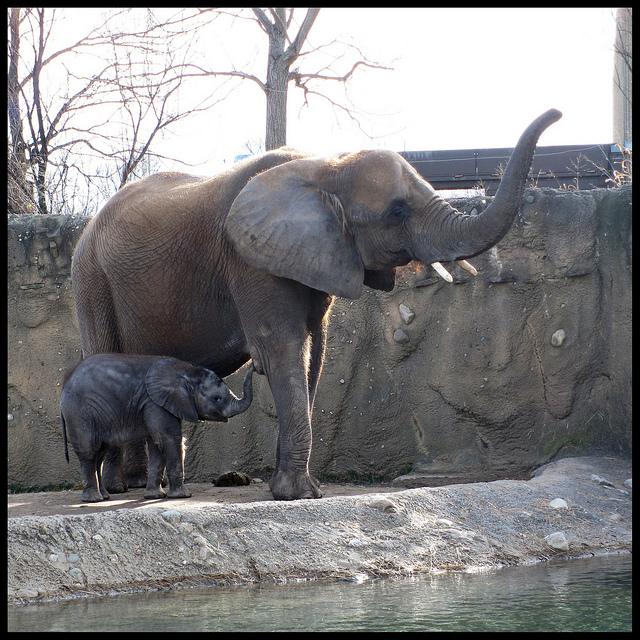Are these elephants real?
Quick response, please. Yes. What are the elephants standing next to?
Write a very short answer. Wall. Are both elephants full grown?
Short answer required. No. 